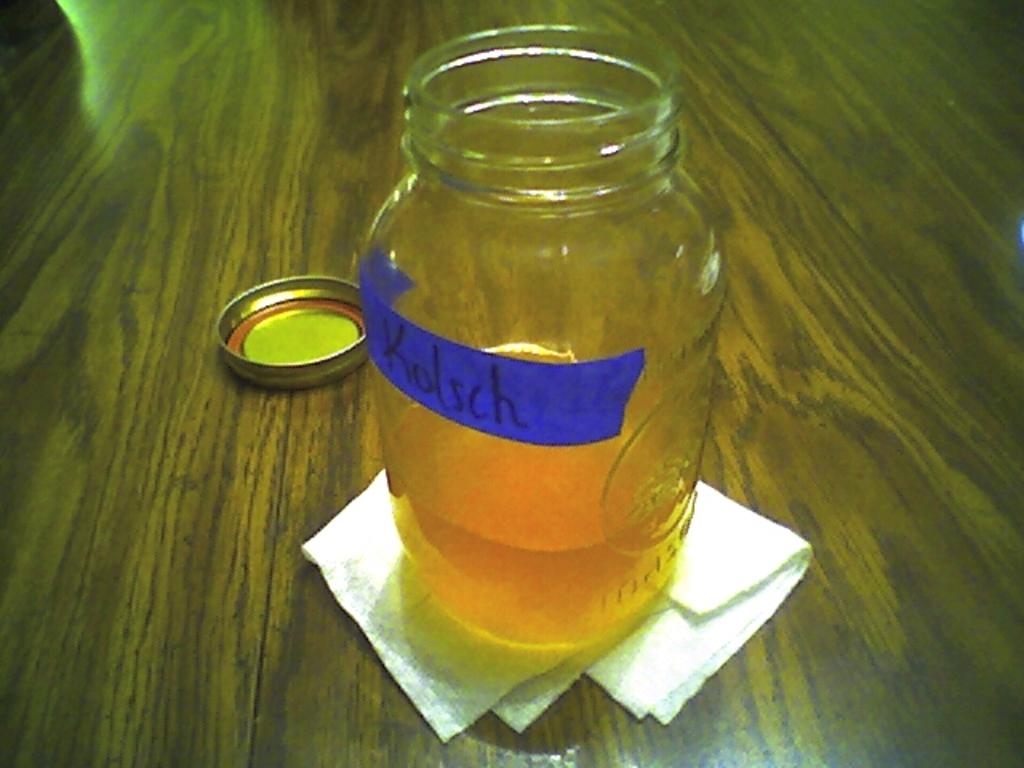<image>
Relay a brief, clear account of the picture shown. the name Kolsch is on the clear jar of liquid 